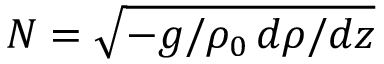Convert formula to latex. <formula><loc_0><loc_0><loc_500><loc_500>N = \sqrt { - g / \rho _ { 0 } \, d \rho / d z }</formula> 